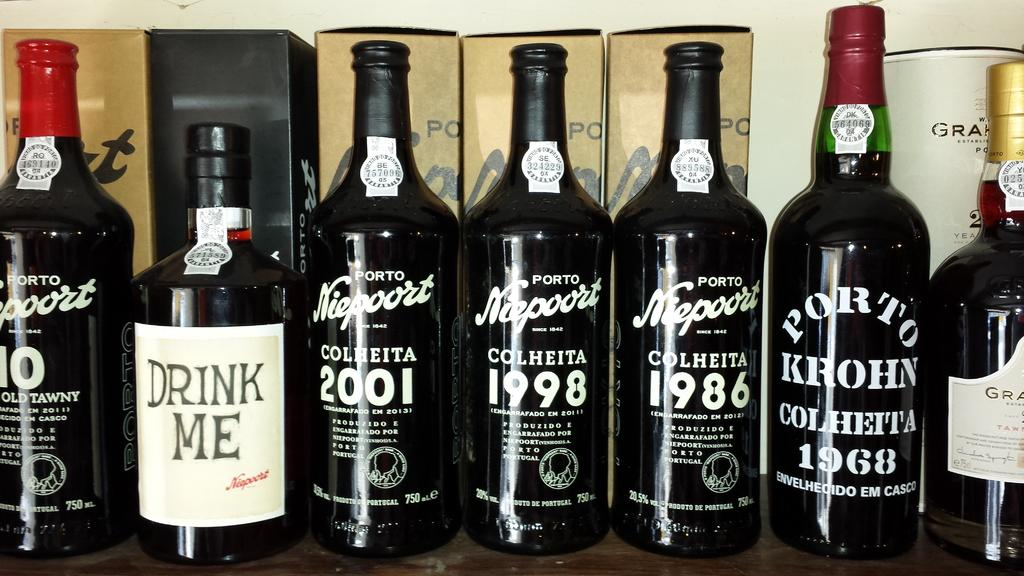<image>
Render a clear and concise summary of the photo. "DRINK ME" is on one of many bottles. 